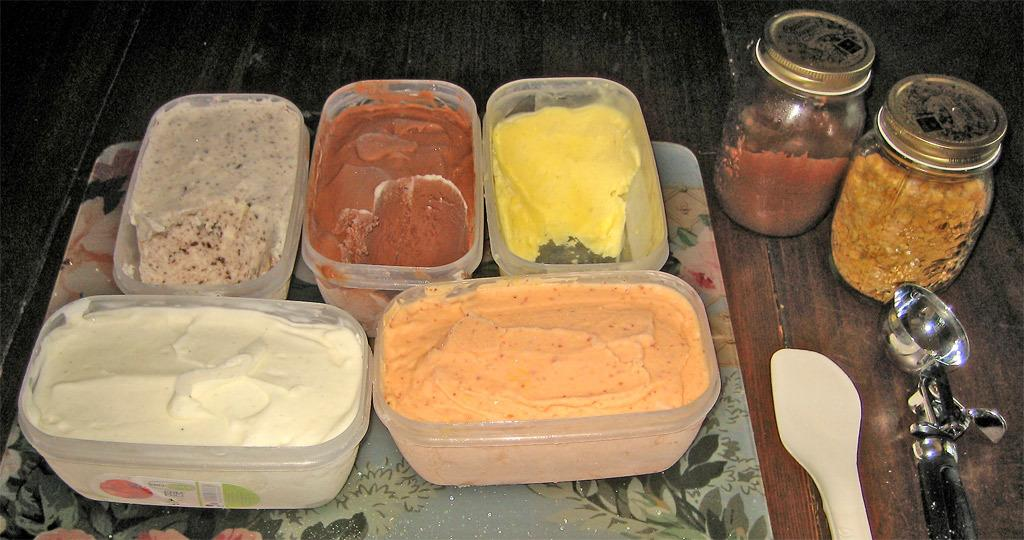What object is present in the image that can hold multiple items? There is a tray in the image that can hold multiple items. What is on the tray? The tray contains ice cream boxes. What can be used to add toppings to the ice cream? There are two jars with toppings in the image. What tool is used to scoop ice cream? There is a scooper in the image. What type of utensils are present in the image? There are white spoons in the image. Can you see a mask being worn by the ice cream in the image? No, there is no mask or any person wearing a mask in the image. Are there any cherries on top of the ice cream boxes? The image does not show any cherries on top of the ice cream boxes. 